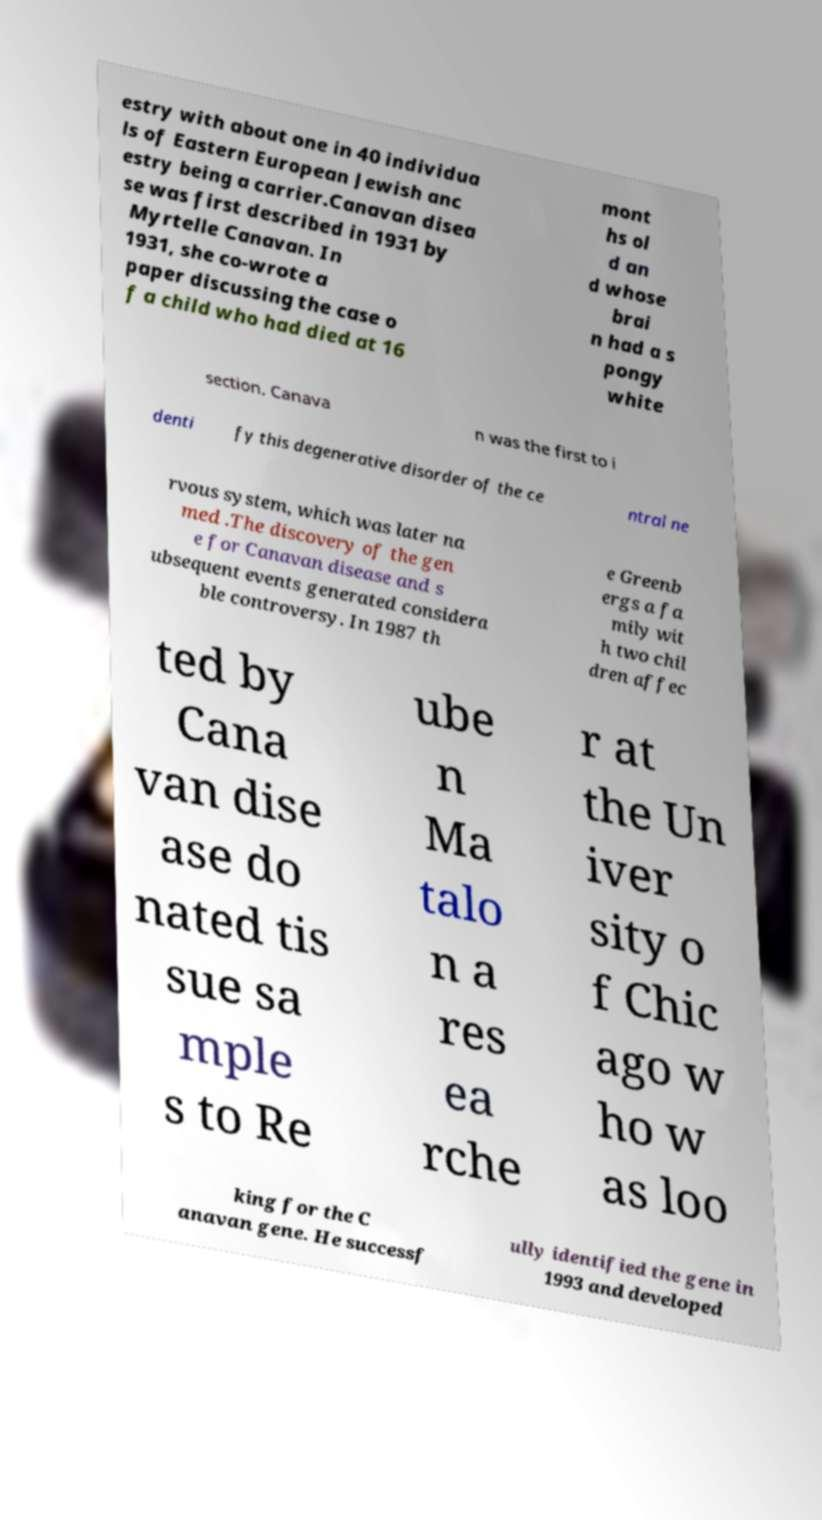What messages or text are displayed in this image? I need them in a readable, typed format. estry with about one in 40 individua ls of Eastern European Jewish anc estry being a carrier.Canavan disea se was first described in 1931 by Myrtelle Canavan. In 1931, she co-wrote a paper discussing the case o f a child who had died at 16 mont hs ol d an d whose brai n had a s pongy white section. Canava n was the first to i denti fy this degenerative disorder of the ce ntral ne rvous system, which was later na med .The discovery of the gen e for Canavan disease and s ubsequent events generated considera ble controversy. In 1987 th e Greenb ergs a fa mily wit h two chil dren affec ted by Cana van dise ase do nated tis sue sa mple s to Re ube n Ma talo n a res ea rche r at the Un iver sity o f Chic ago w ho w as loo king for the C anavan gene. He successf ully identified the gene in 1993 and developed 